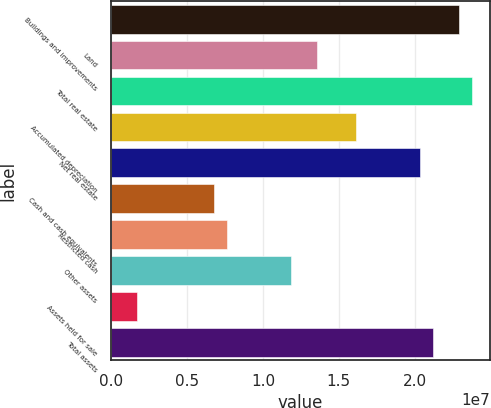Convert chart. <chart><loc_0><loc_0><loc_500><loc_500><bar_chart><fcel>Buildings and improvements<fcel>Land<fcel>Total real estate<fcel>Accumulated depreciation<fcel>Net real estate<fcel>Cash and cash equivalents<fcel>Restricted cash<fcel>Other assets<fcel>Assets held for sale<fcel>Total assets<nl><fcel>2.29125e+07<fcel>1.35778e+07<fcel>2.37612e+07<fcel>1.61237e+07<fcel>2.03667e+07<fcel>6.78894e+06<fcel>7.63756e+06<fcel>1.18806e+07<fcel>1.69728e+06<fcel>2.12153e+07<nl></chart> 